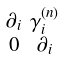<formula> <loc_0><loc_0><loc_500><loc_500>\begin{smallmatrix} \partial _ { i } & \gamma _ { i } ^ { ( n ) } \\ 0 & \partial _ { i } \end{smallmatrix}</formula> 